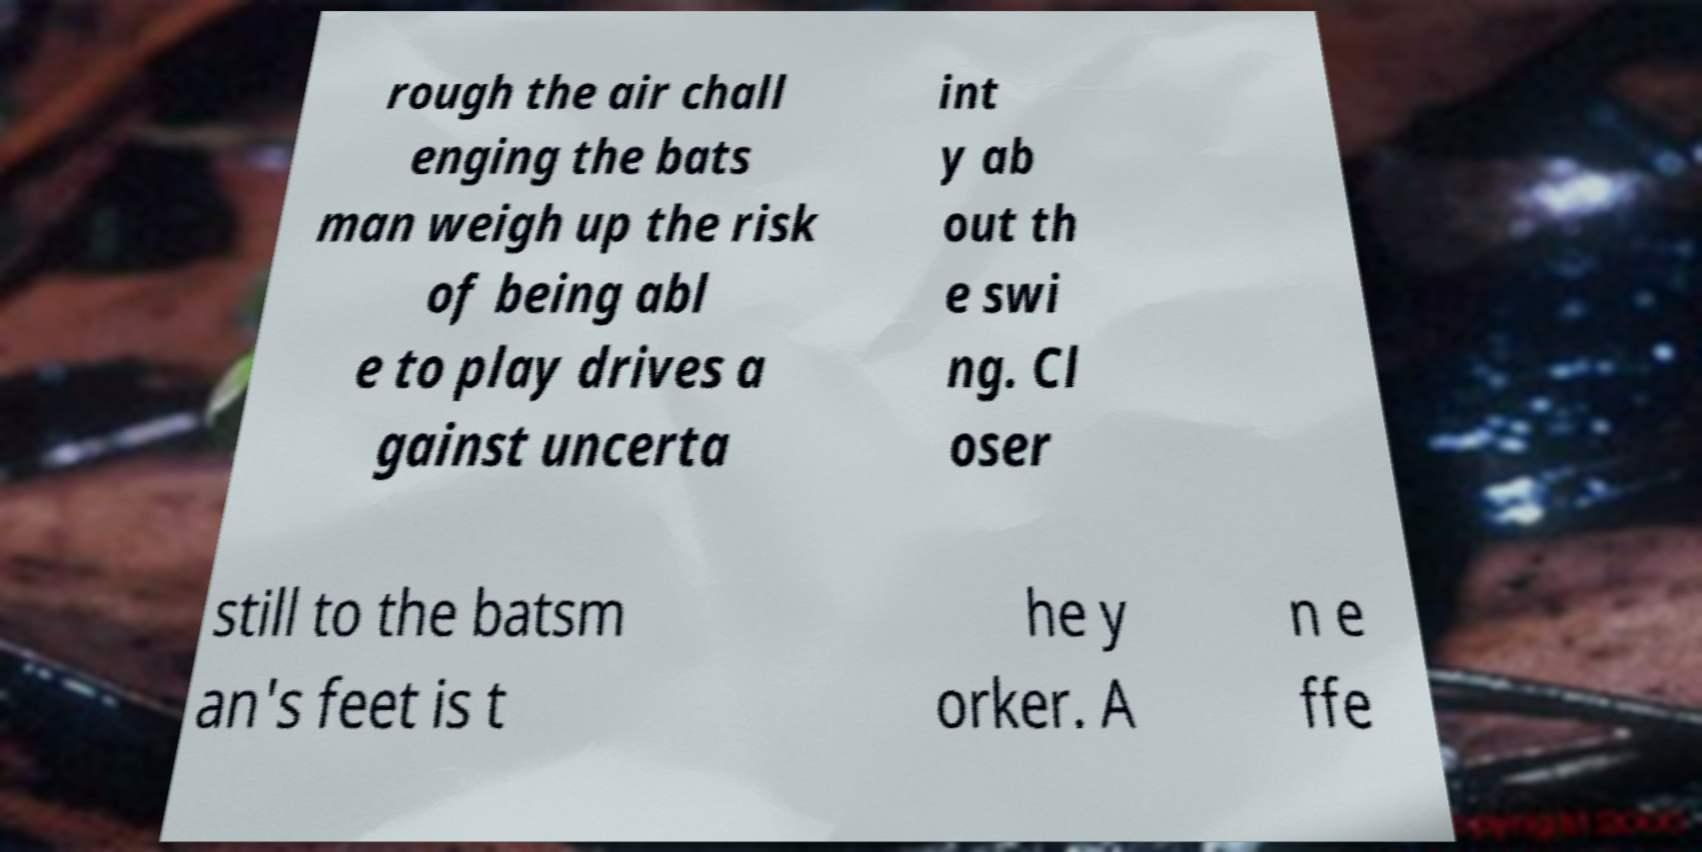What messages or text are displayed in this image? I need them in a readable, typed format. rough the air chall enging the bats man weigh up the risk of being abl e to play drives a gainst uncerta int y ab out th e swi ng. Cl oser still to the batsm an's feet is t he y orker. A n e ffe 